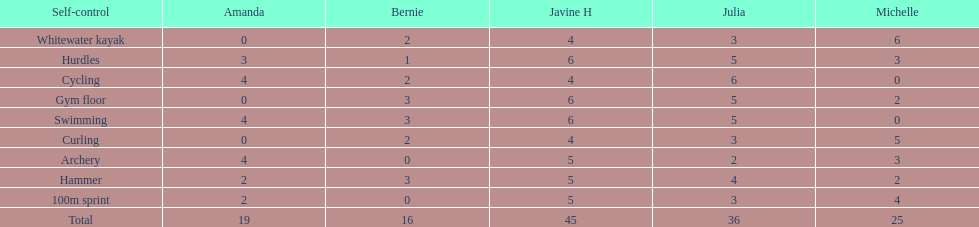What are the number of points bernie scored in hurdles? 1. 